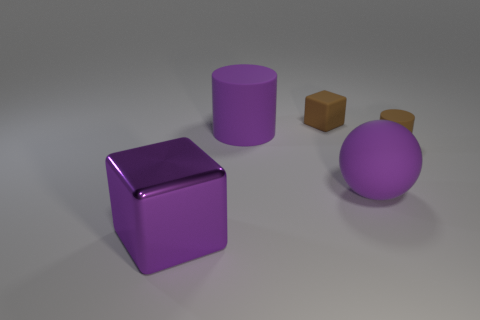Add 3 purple shiny balls. How many objects exist? 8 Subtract all cylinders. How many objects are left? 3 Add 3 yellow matte blocks. How many yellow matte blocks exist? 3 Subtract 0 red balls. How many objects are left? 5 Subtract all small purple cylinders. Subtract all purple shiny things. How many objects are left? 4 Add 2 big purple matte cylinders. How many big purple matte cylinders are left? 3 